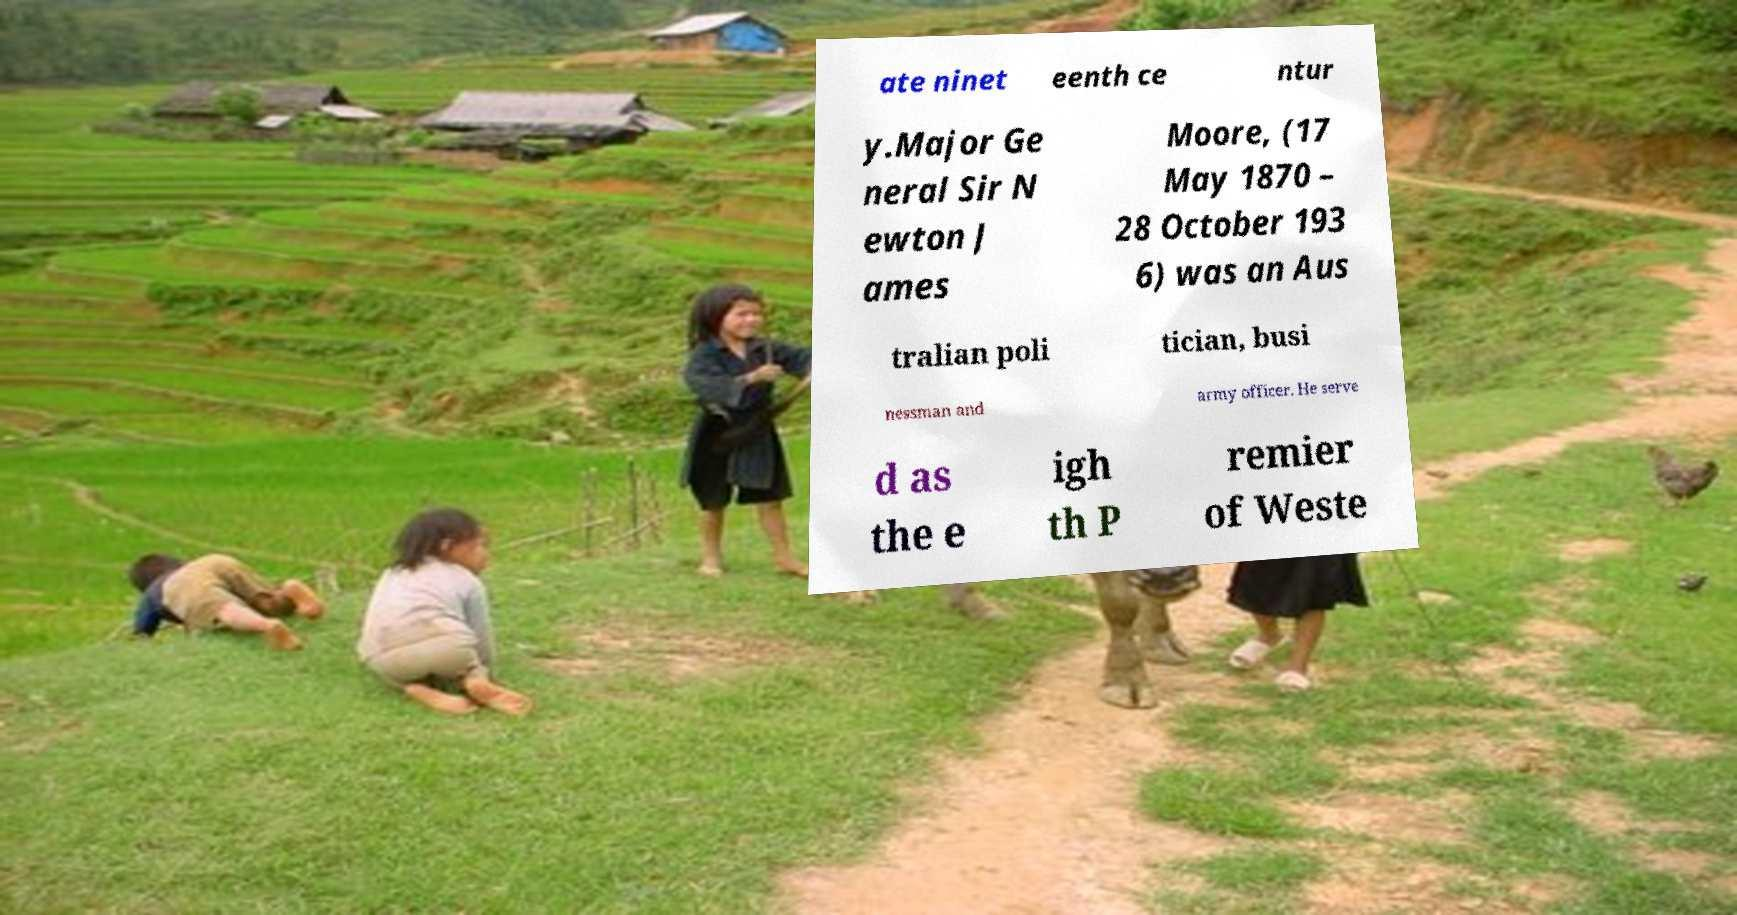Please identify and transcribe the text found in this image. ate ninet eenth ce ntur y.Major Ge neral Sir N ewton J ames Moore, (17 May 1870 – 28 October 193 6) was an Aus tralian poli tician, busi nessman and army officer. He serve d as the e igh th P remier of Weste 